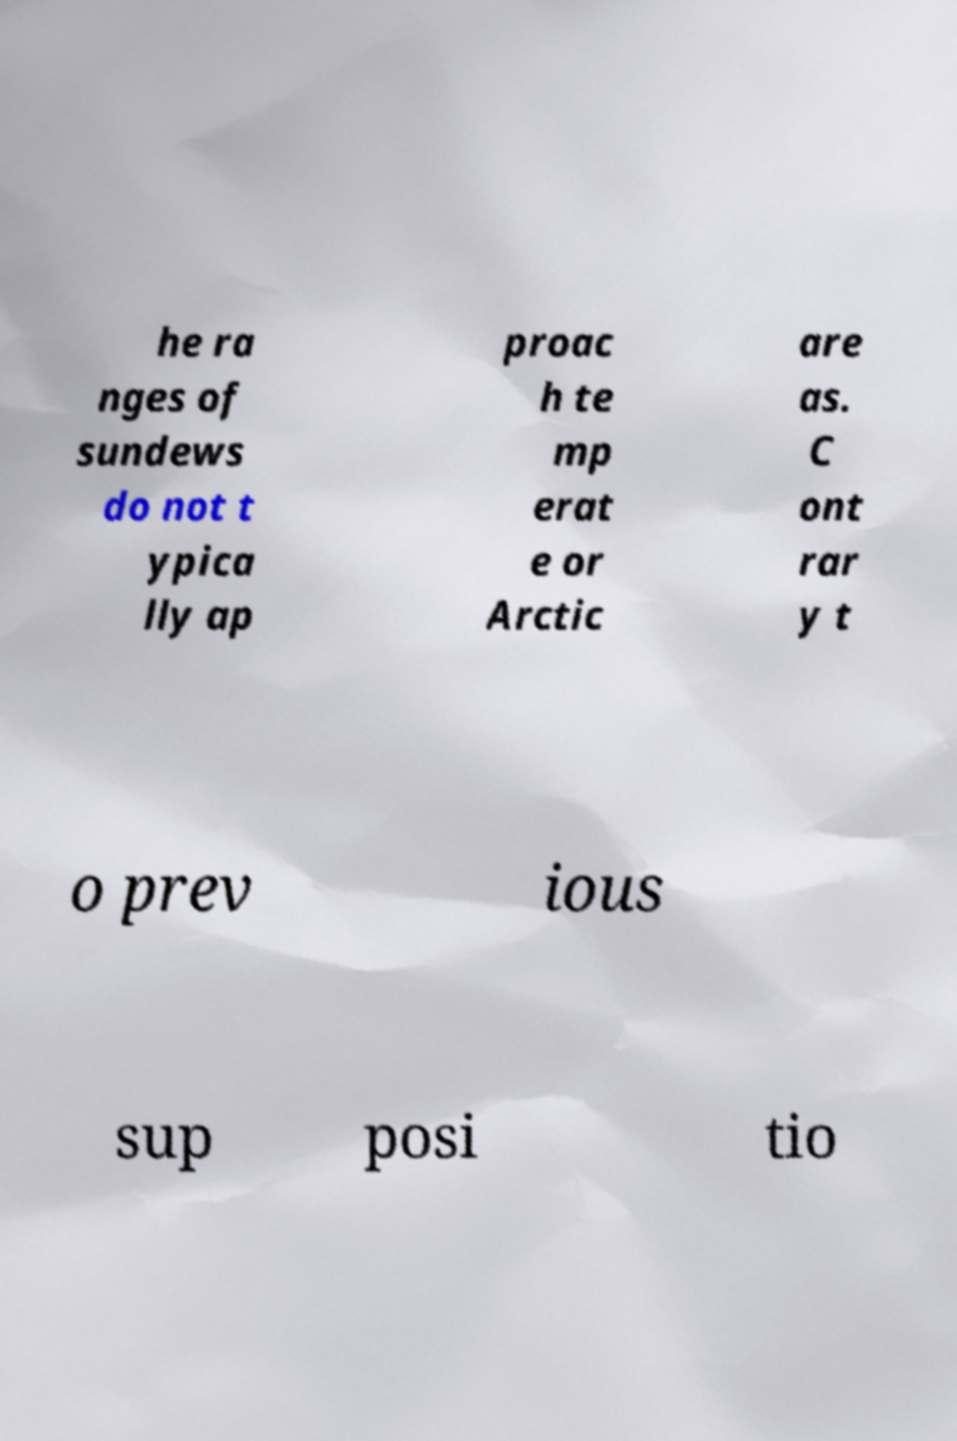Please read and relay the text visible in this image. What does it say? he ra nges of sundews do not t ypica lly ap proac h te mp erat e or Arctic are as. C ont rar y t o prev ious sup posi tio 